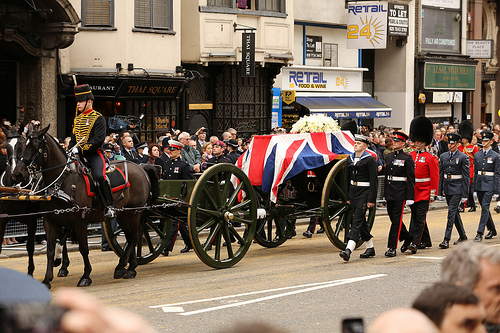Where is the sign? The sign is situated at a restaurant. 